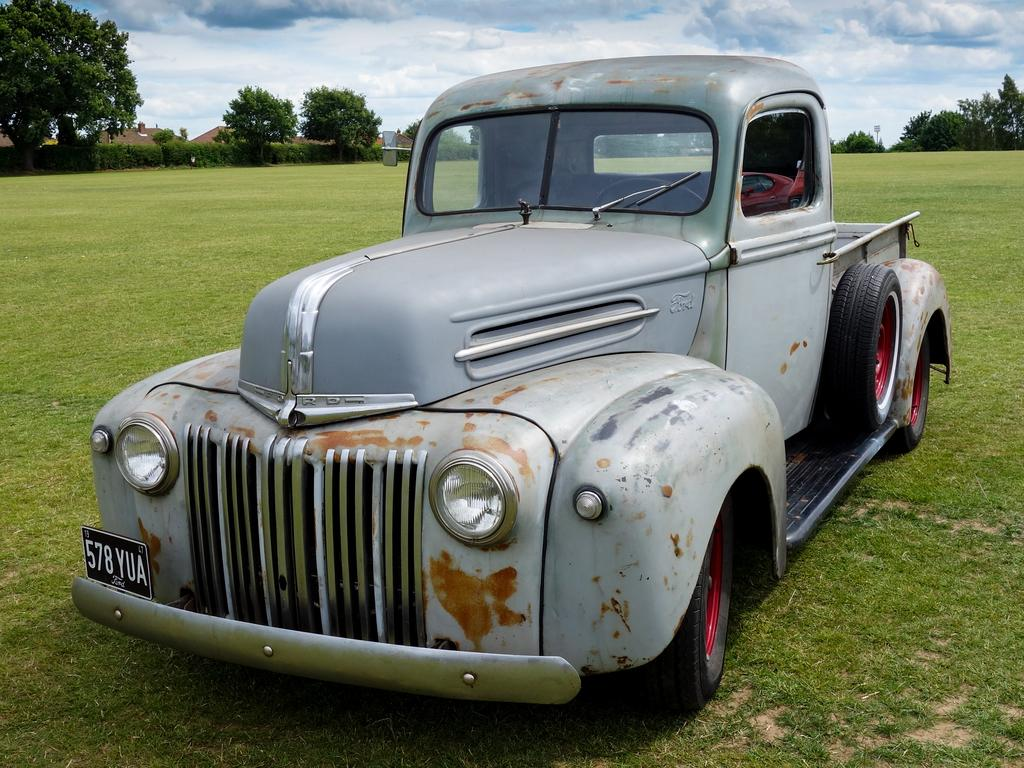What type of vehicle is in the image? There is a gray color vehicle in the image. Where is the vehicle located? The vehicle is on the grass. What can be seen in the background of the image? There are trees, houses, plants, and clouds in the sky in the background of the image. How many firemen are standing next to the tree in the image? There are no firemen or trees present in the image. 